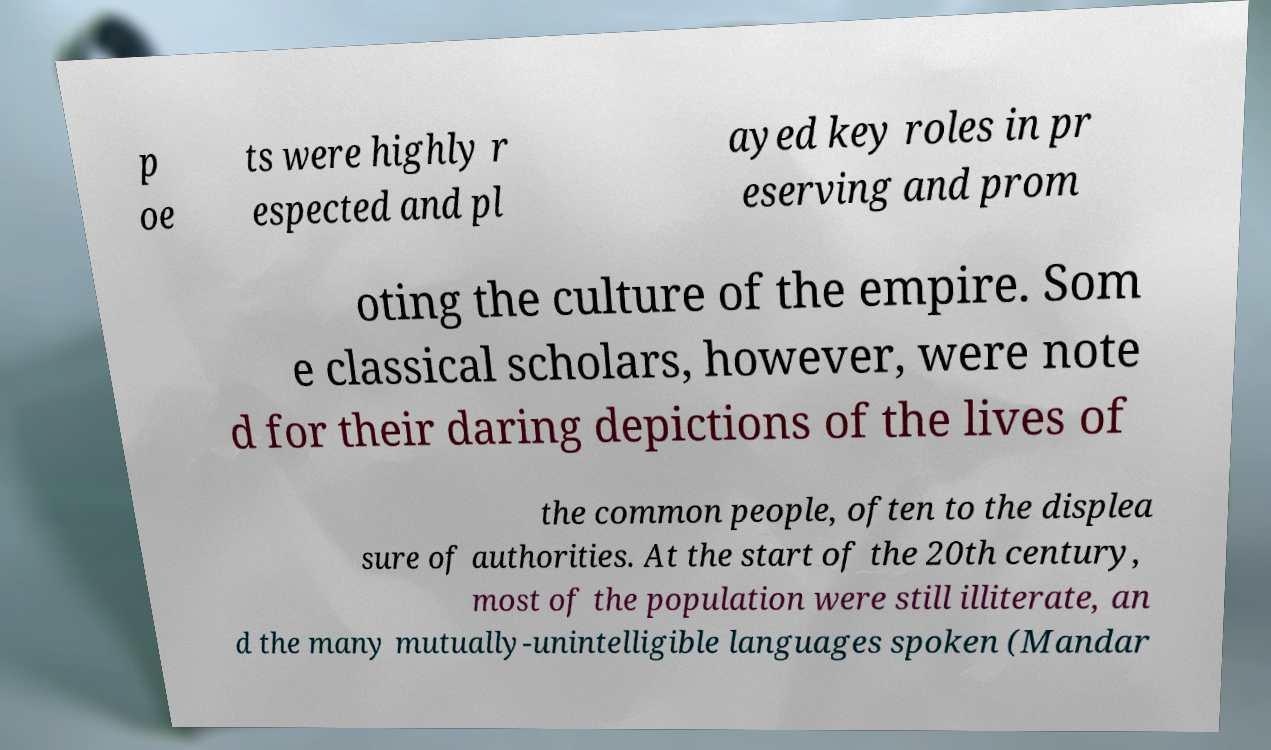Could you assist in decoding the text presented in this image and type it out clearly? p oe ts were highly r espected and pl ayed key roles in pr eserving and prom oting the culture of the empire. Som e classical scholars, however, were note d for their daring depictions of the lives of the common people, often to the displea sure of authorities. At the start of the 20th century, most of the population were still illiterate, an d the many mutually-unintelligible languages spoken (Mandar 